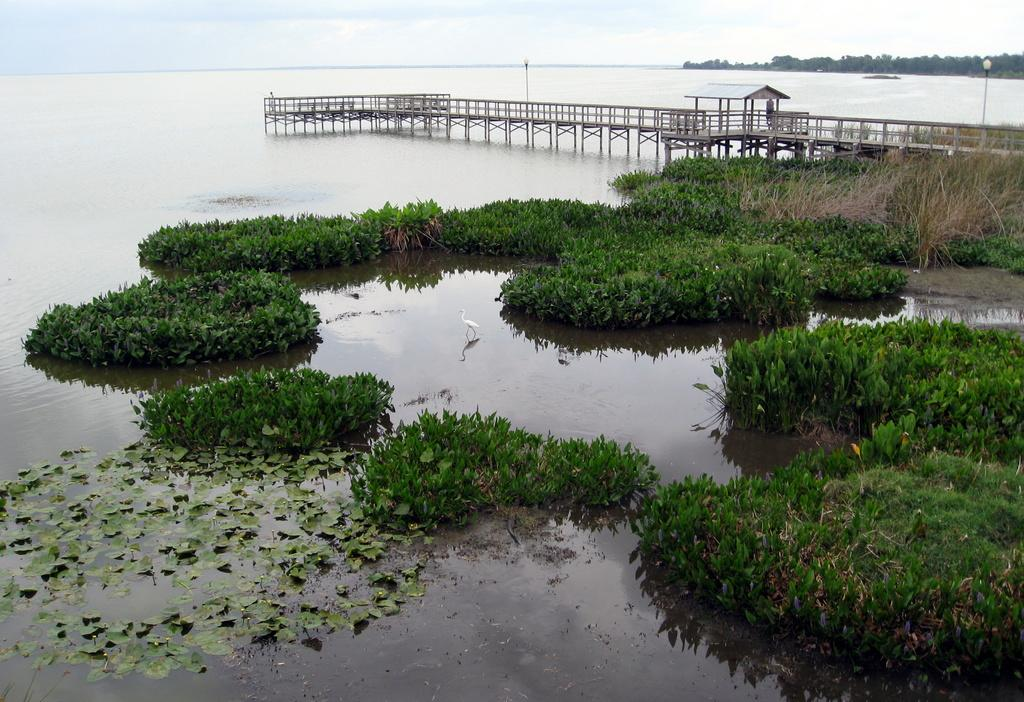What animal can be seen in the water in the image? There is a duck in the water in the image. What type of vegetation is present in the image? There are plants and leaves visible in the image. What structure is present over the river in the image? There is a bridge over the river in the image. What can be seen in the background of the image? There are trees, street lights, and the sky visible in the background of the image. What type of grass is being used as a vessel in the image? There is no grass being used as a vessel in the image; the image features a duck in the water, plants, leaves, a bridge, trees, street lights, and the sky. 